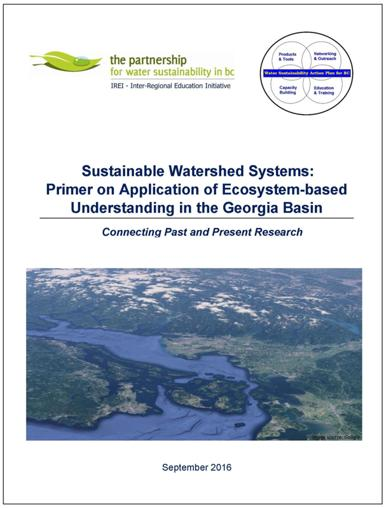What is the title of the publication mentioned in the image? The title of the publication is "Sustainable Watershed Systems: Primer on Application of Ecosystem-based Understanding in the Georgia Basin." Who is responsible for this publication? The Partnership for Water Sustainability in BC and the Inter-Regional Education Initiative (IREI) are responsible for this publication. What is the main focus of this publication? The main focus of the publication is on the application of ecosystem-based understanding in the Georgia Basin, aiming to connect past and present research on sustainable watershed systems. 